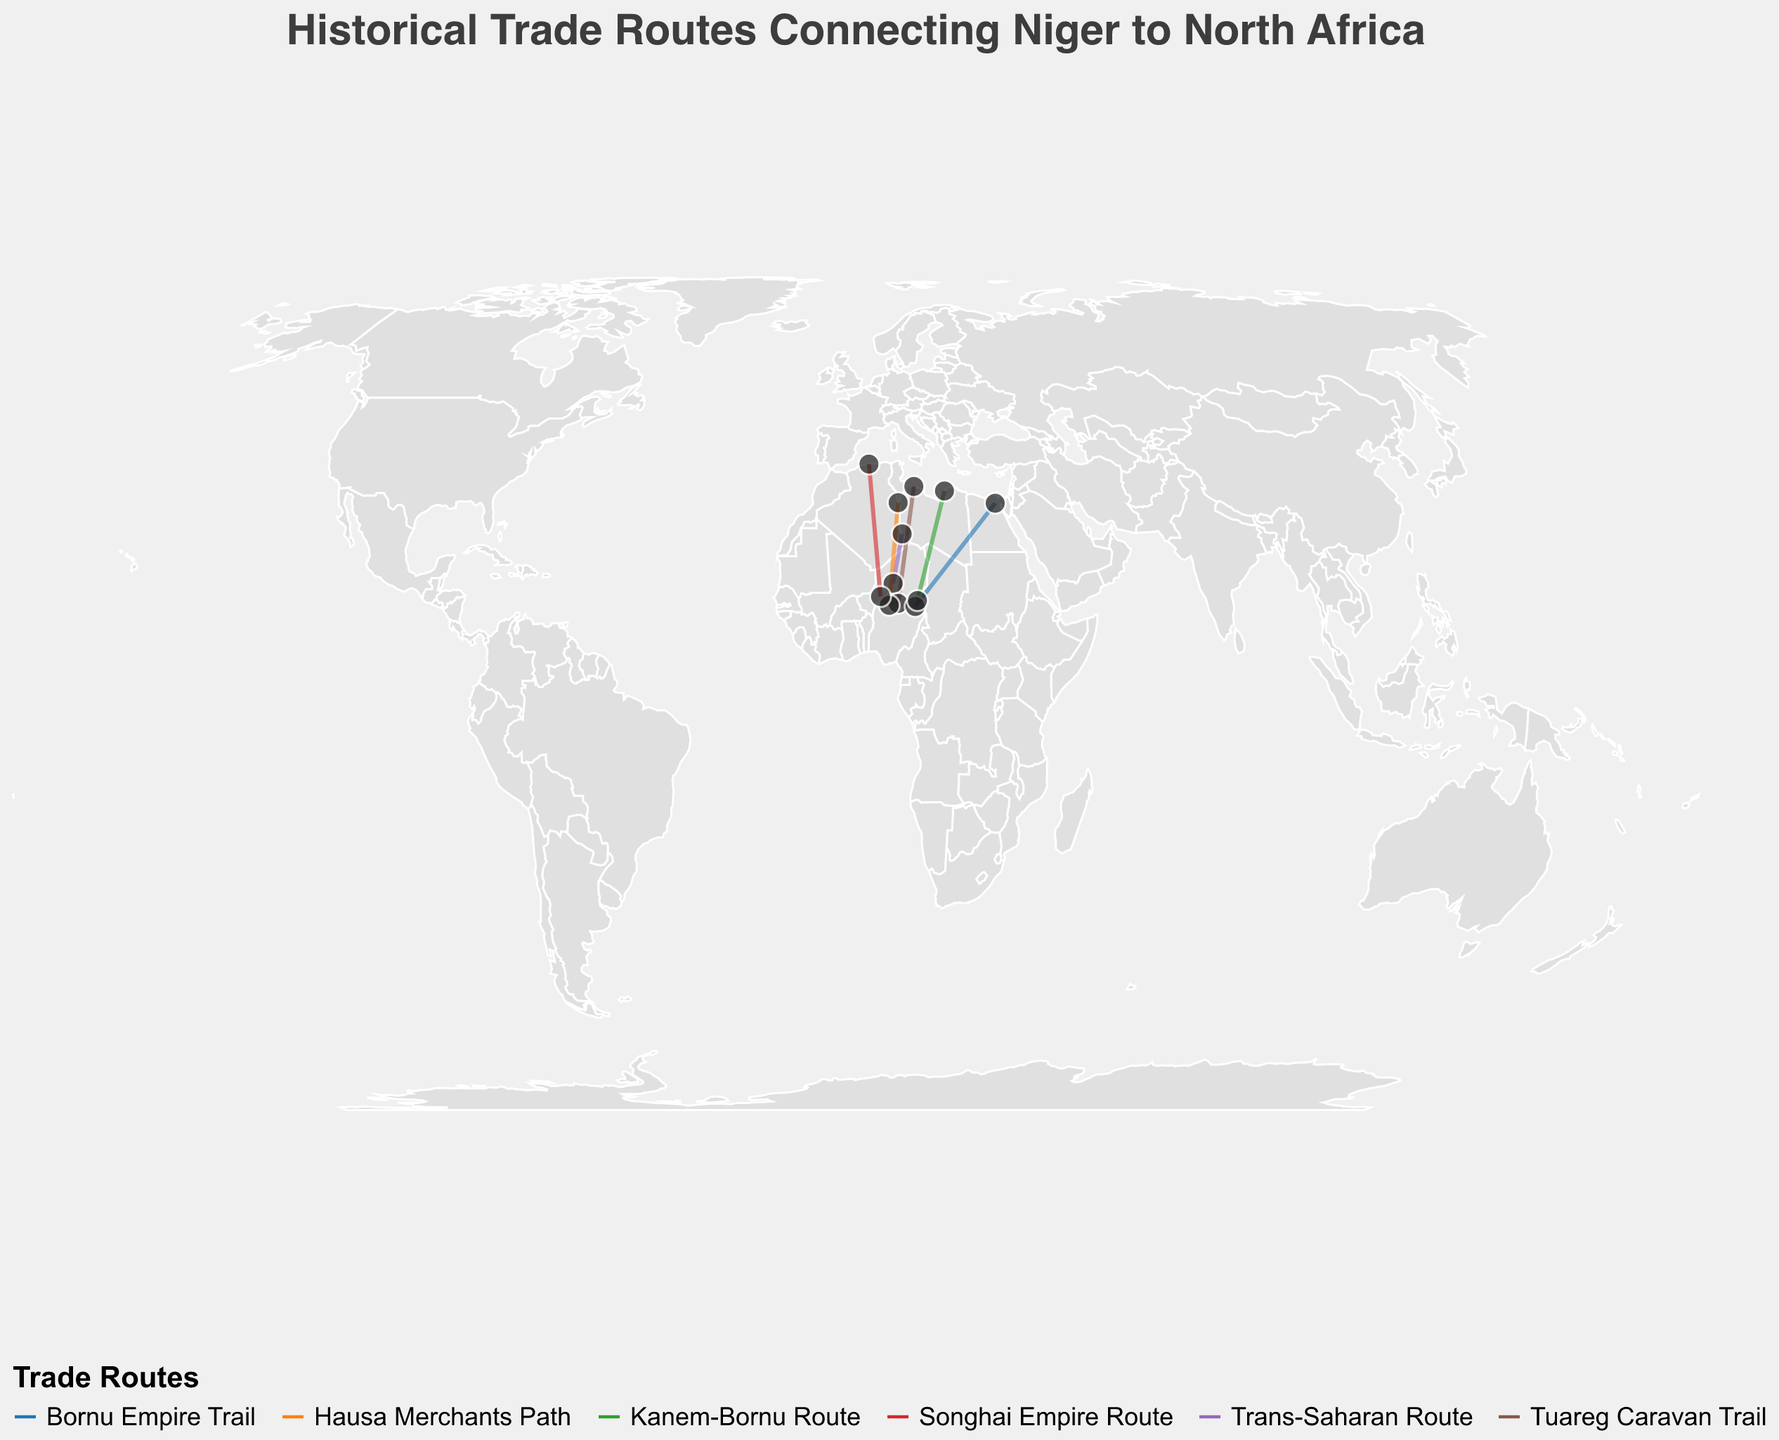What is the title of the plot? The title is displayed at the top of the plot. It reads "Historical Trade Routes Connecting Niger to North Africa".
Answer: Historical Trade Routes Connecting Niger to North Africa Which route connected Agadez to Ghat? Locate the starting point 'Agadez' and the ending point 'Ghat' on the plot. The route connecting these two points is labeled 'Trans-Saharan Route'.
Answer: Trans-Saharan Route What types of goods were traded along the Hausa Merchants Path? By inspecting the tooltip for 'Hausa Merchants Path', it lists 'Leather and Ivory' as the goods traded.
Answer: Leather and Ivory Which trade route ends in Cairo? Observe the endpoints of all routes. The route that ends in Cairo is labeled 'Bornu Empire Trail'.
Answer: Bornu Empire Trail What is the longest trade route in terms of latitude difference? Compare the latitudes of start and end points for each route. The route with the greatest difference is the Tuareg Caravan Trail, ranging from Zinder (13.8070) to Tripoli (32.8872). Calculation: 32.8872 - 13.8070 = 19.08.
Answer: Tuareg Caravan Trail Which trade route trades in slaves and kola nuts? Hover over the routes to read the tool tips. The 'Songhai Empire Route' deals in slaves and kola nuts.
Answer: Songhai Empire Route Which route spans the widest range of longitude? Compare the longitudes of start and end points for each route. The 'Bornu Empire Trail' runs from Diffa (12.6114) to Cairo (31.2357). Calculation: 31.2357 - 12.6114 = 18.6243.
Answer: Bornu Empire Trail Which route starts at Maradi? Identify the 'Start' points on the plot. The start point 'Maradi' corresponds to the 'Hausa Merchants Path'.
Answer: Hausa Merchants Path Which country does the endpoint of the Kanem-Bornu Route lie in? Observe the endpoint 'Benghazi' of the Kanem-Bornu Route, which is situated in Libya.
Answer: Libya 